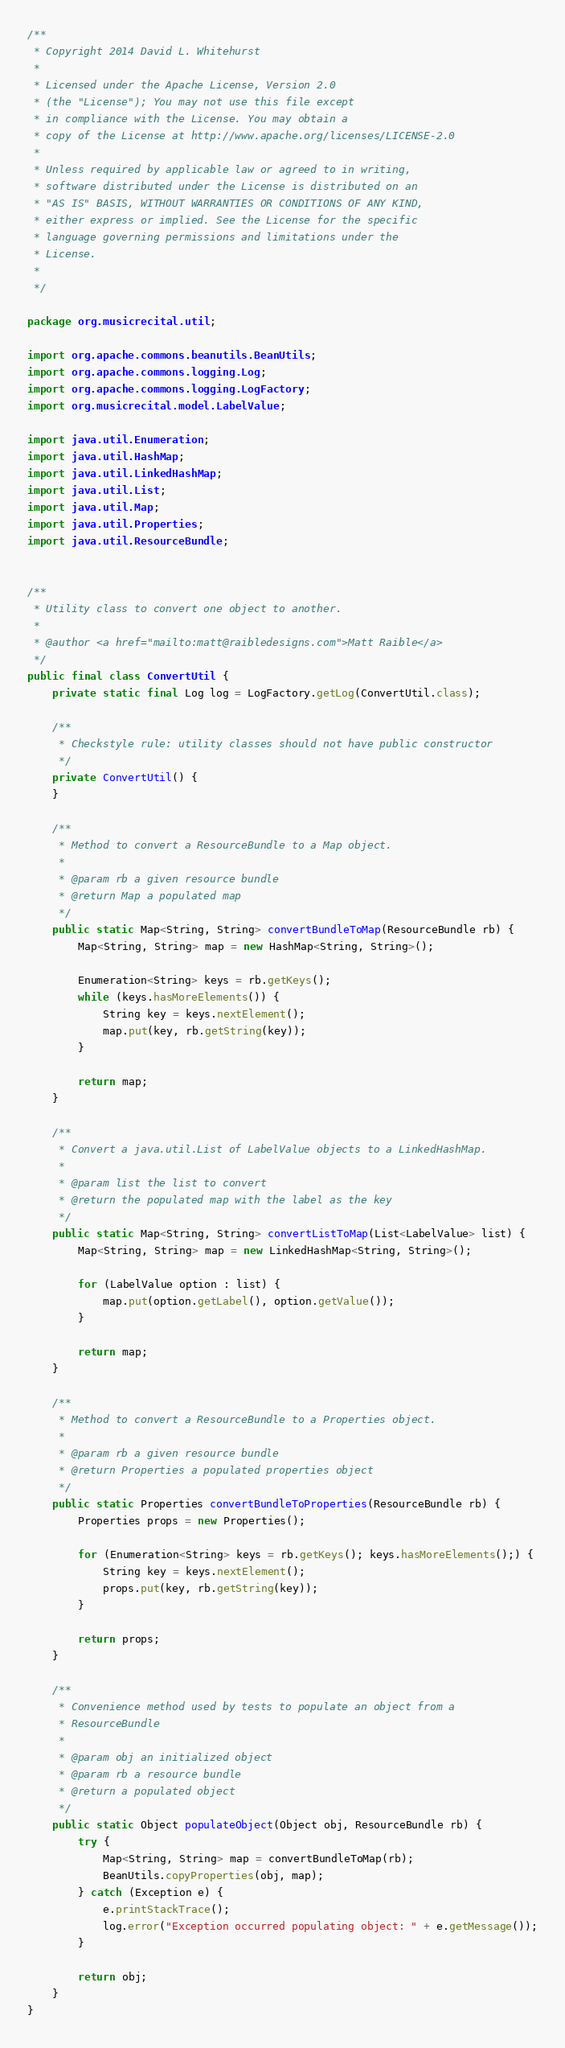Convert code to text. <code><loc_0><loc_0><loc_500><loc_500><_Java_>/**
 * Copyright 2014 David L. Whitehurst
 * 
 * Licensed under the Apache License, Version 2.0 
 * (the "License"); You may not use this file except 
 * in compliance with the License. You may obtain a 
 * copy of the License at http://www.apache.org/licenses/LICENSE-2.0
 *
 * Unless required by applicable law or agreed to in writing, 
 * software distributed under the License is distributed on an 
 * "AS IS" BASIS, WITHOUT WARRANTIES OR CONDITIONS OF ANY KIND, 
 * either express or implied. See the License for the specific 
 * language governing permissions and limitations under the 
 * License.
 * 
 */

package org.musicrecital.util;

import org.apache.commons.beanutils.BeanUtils;
import org.apache.commons.logging.Log;
import org.apache.commons.logging.LogFactory;
import org.musicrecital.model.LabelValue;

import java.util.Enumeration;
import java.util.HashMap;
import java.util.LinkedHashMap;
import java.util.List;
import java.util.Map;
import java.util.Properties;
import java.util.ResourceBundle;


/**
 * Utility class to convert one object to another.
 *
 * @author <a href="mailto:matt@raibledesigns.com">Matt Raible</a>
 */
public final class ConvertUtil {
    private static final Log log = LogFactory.getLog(ConvertUtil.class);

    /**
     * Checkstyle rule: utility classes should not have public constructor
     */
    private ConvertUtil() {
    }

    /**
     * Method to convert a ResourceBundle to a Map object.
     *
     * @param rb a given resource bundle
     * @return Map a populated map
     */
    public static Map<String, String> convertBundleToMap(ResourceBundle rb) {
        Map<String, String> map = new HashMap<String, String>();

        Enumeration<String> keys = rb.getKeys();
        while (keys.hasMoreElements()) {
            String key = keys.nextElement();
            map.put(key, rb.getString(key));
        }

        return map;
    }

    /**
     * Convert a java.util.List of LabelValue objects to a LinkedHashMap.
     *
     * @param list the list to convert
     * @return the populated map with the label as the key
     */
    public static Map<String, String> convertListToMap(List<LabelValue> list) {
        Map<String, String> map = new LinkedHashMap<String, String>();

        for (LabelValue option : list) {
            map.put(option.getLabel(), option.getValue());
        }

        return map;
    }

    /**
     * Method to convert a ResourceBundle to a Properties object.
     *
     * @param rb a given resource bundle
     * @return Properties a populated properties object
     */
    public static Properties convertBundleToProperties(ResourceBundle rb) {
        Properties props = new Properties();

        for (Enumeration<String> keys = rb.getKeys(); keys.hasMoreElements();) {
            String key = keys.nextElement();
            props.put(key, rb.getString(key));
        }

        return props;
    }

    /**
     * Convenience method used by tests to populate an object from a
     * ResourceBundle
     *
     * @param obj an initialized object
     * @param rb a resource bundle
     * @return a populated object
     */
    public static Object populateObject(Object obj, ResourceBundle rb) {
        try {
            Map<String, String> map = convertBundleToMap(rb);
            BeanUtils.copyProperties(obj, map);
        } catch (Exception e) {
            e.printStackTrace();
            log.error("Exception occurred populating object: " + e.getMessage());
        }

        return obj;
    }
}
</code> 